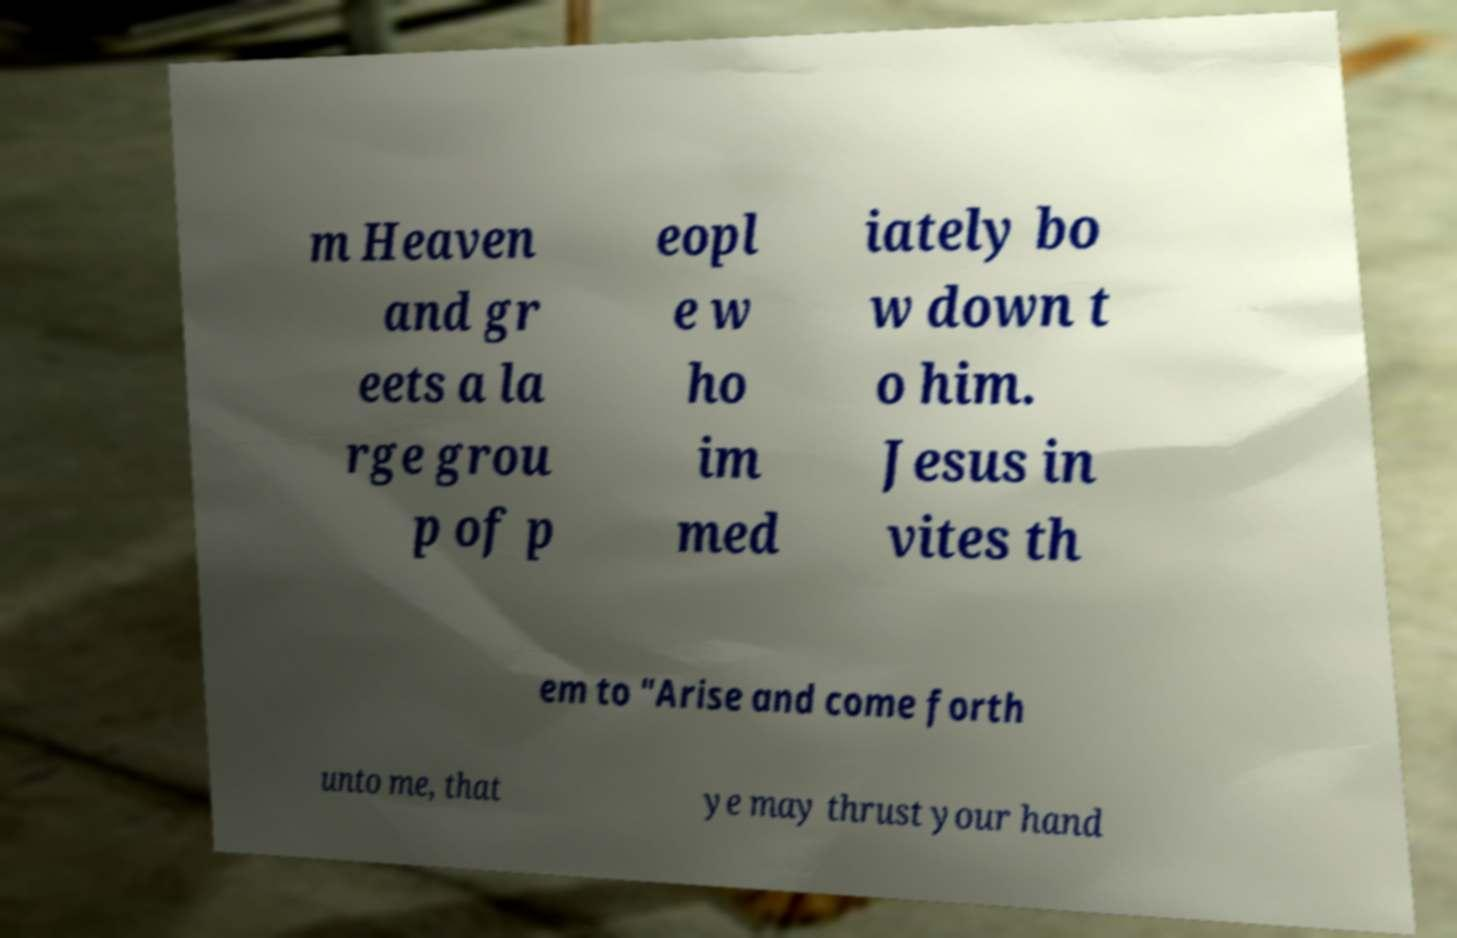What messages or text are displayed in this image? I need them in a readable, typed format. m Heaven and gr eets a la rge grou p of p eopl e w ho im med iately bo w down t o him. Jesus in vites th em to "Arise and come forth unto me, that ye may thrust your hand 